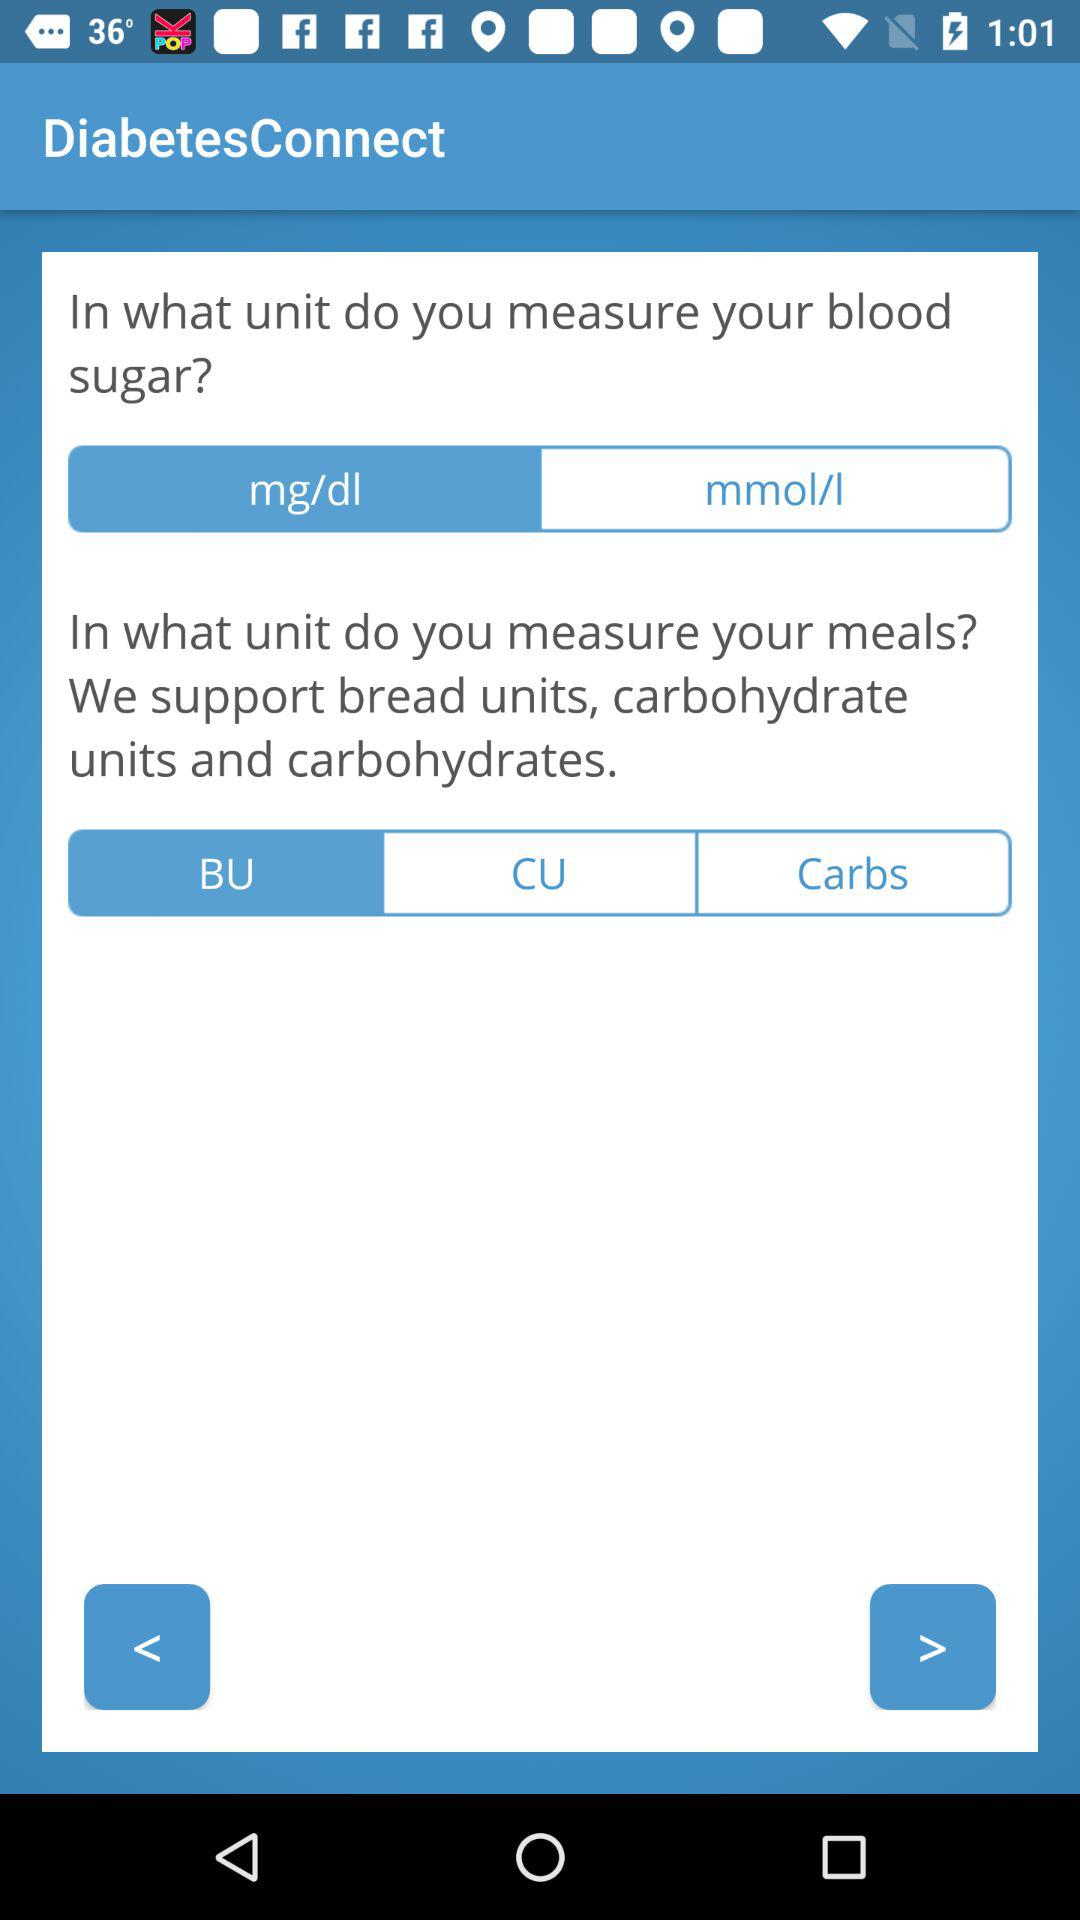What is the application name? The application name is "DiabetesConnect". 